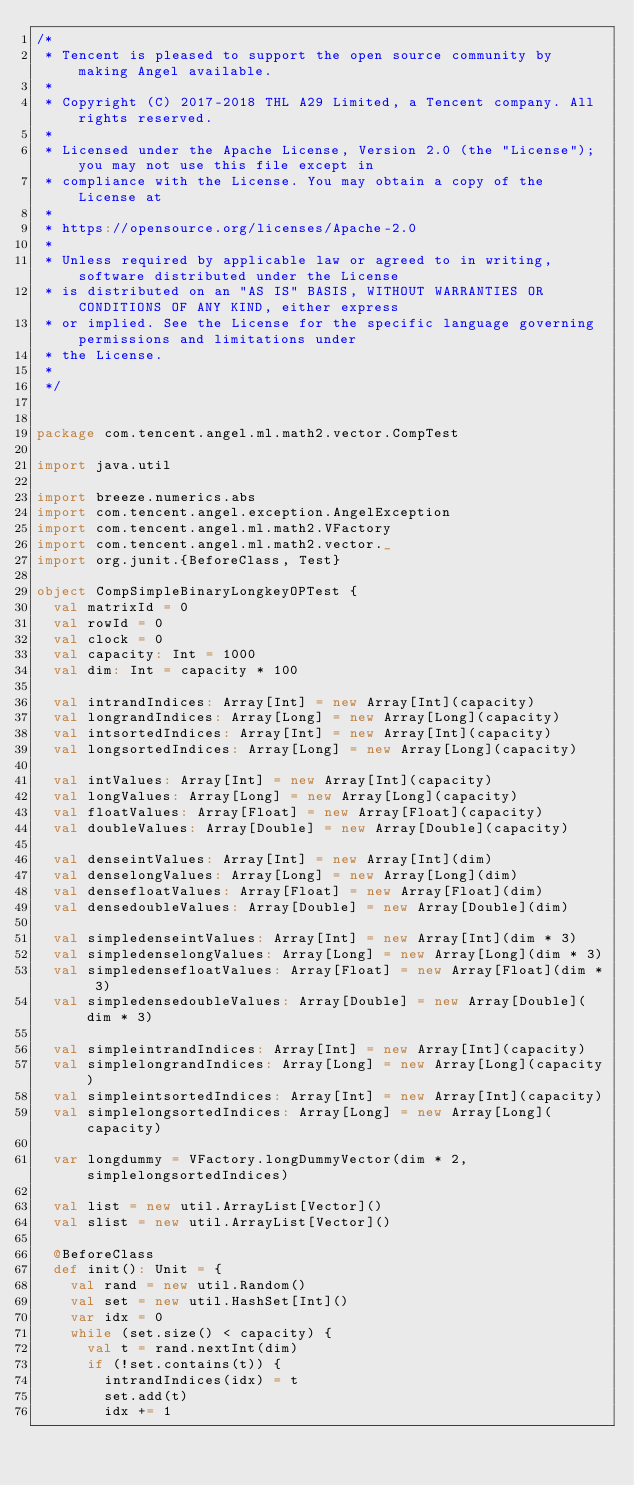Convert code to text. <code><loc_0><loc_0><loc_500><loc_500><_Scala_>/*
 * Tencent is pleased to support the open source community by making Angel available.
 *
 * Copyright (C) 2017-2018 THL A29 Limited, a Tencent company. All rights reserved.
 *
 * Licensed under the Apache License, Version 2.0 (the "License"); you may not use this file except in 
 * compliance with the License. You may obtain a copy of the License at
 *
 * https://opensource.org/licenses/Apache-2.0
 *
 * Unless required by applicable law or agreed to in writing, software distributed under the License
 * is distributed on an "AS IS" BASIS, WITHOUT WARRANTIES OR CONDITIONS OF ANY KIND, either express
 * or implied. See the License for the specific language governing permissions and limitations under
 * the License.
 *
 */


package com.tencent.angel.ml.math2.vector.CompTest

import java.util

import breeze.numerics.abs
import com.tencent.angel.exception.AngelException
import com.tencent.angel.ml.math2.VFactory
import com.tencent.angel.ml.math2.vector._
import org.junit.{BeforeClass, Test}

object CompSimpleBinaryLongkeyOPTest {
  val matrixId = 0
  val rowId = 0
  val clock = 0
  val capacity: Int = 1000
  val dim: Int = capacity * 100

  val intrandIndices: Array[Int] = new Array[Int](capacity)
  val longrandIndices: Array[Long] = new Array[Long](capacity)
  val intsortedIndices: Array[Int] = new Array[Int](capacity)
  val longsortedIndices: Array[Long] = new Array[Long](capacity)

  val intValues: Array[Int] = new Array[Int](capacity)
  val longValues: Array[Long] = new Array[Long](capacity)
  val floatValues: Array[Float] = new Array[Float](capacity)
  val doubleValues: Array[Double] = new Array[Double](capacity)

  val denseintValues: Array[Int] = new Array[Int](dim)
  val denselongValues: Array[Long] = new Array[Long](dim)
  val densefloatValues: Array[Float] = new Array[Float](dim)
  val densedoubleValues: Array[Double] = new Array[Double](dim)

  val simpledenseintValues: Array[Int] = new Array[Int](dim * 3)
  val simpledenselongValues: Array[Long] = new Array[Long](dim * 3)
  val simpledensefloatValues: Array[Float] = new Array[Float](dim * 3)
  val simpledensedoubleValues: Array[Double] = new Array[Double](dim * 3)

  val simpleintrandIndices: Array[Int] = new Array[Int](capacity)
  val simplelongrandIndices: Array[Long] = new Array[Long](capacity)
  val simpleintsortedIndices: Array[Int] = new Array[Int](capacity)
  val simplelongsortedIndices: Array[Long] = new Array[Long](capacity)

  var longdummy = VFactory.longDummyVector(dim * 2, simplelongsortedIndices)

  val list = new util.ArrayList[Vector]()
  val slist = new util.ArrayList[Vector]()

  @BeforeClass
  def init(): Unit = {
    val rand = new util.Random()
    val set = new util.HashSet[Int]()
    var idx = 0
    while (set.size() < capacity) {
      val t = rand.nextInt(dim)
      if (!set.contains(t)) {
        intrandIndices(idx) = t
        set.add(t)
        idx += 1</code> 